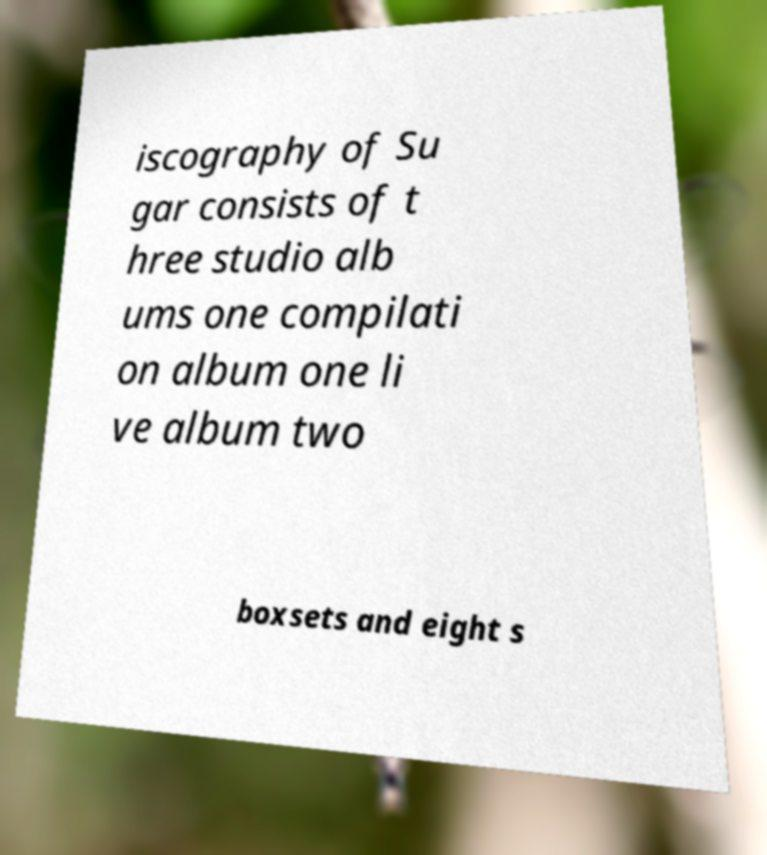Can you accurately transcribe the text from the provided image for me? iscography of Su gar consists of t hree studio alb ums one compilati on album one li ve album two boxsets and eight s 